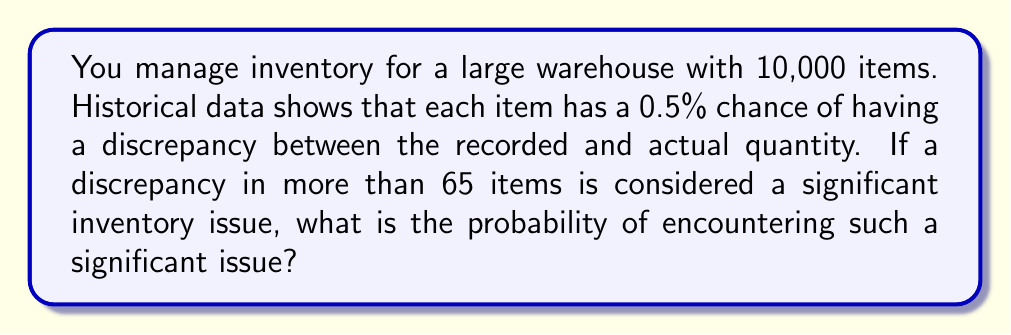Teach me how to tackle this problem. To solve this problem, we'll use the binomial distribution and then apply the normal approximation due to the large number of trials.

1. Identify the parameters:
   $n = 10,000$ (number of items)
   $p = 0.005$ (probability of discrepancy for each item)
   $X =$ number of items with discrepancies

2. Calculate mean and standard deviation:
   $\mu = np = 10,000 \times 0.005 = 50$
   $\sigma = \sqrt{np(1-p)} = \sqrt{10,000 \times 0.005 \times 0.995} \approx 7.0534$

3. We want $P(X > 65)$, which is equivalent to $P(X \geq 66)$ since $X$ is discrete.

4. Apply the continuity correction and calculate the z-score:
   $z = \frac{65.5 - \mu}{\sigma} = \frac{65.5 - 50}{7.0534} \approx 2.1975$

5. Use the standard normal distribution to find the probability:
   $P(X \geq 66) \approx P(Z > 2.1975)$
   $= 1 - P(Z \leq 2.1975)$
   $= 1 - 0.9860$ (using a standard normal table or calculator)
   $= 0.0140$

Therefore, the probability of encountering a significant inventory issue (more than 65 items with discrepancies) is approximately 0.0140 or 1.40%.
Answer: 0.0140 or 1.40% 